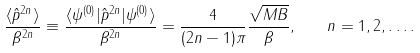<formula> <loc_0><loc_0><loc_500><loc_500>\frac { \langle \hat { p } ^ { 2 n } \rangle } { \beta ^ { 2 n } } \equiv \frac { \langle \psi ^ { ( 0 ) } | \hat { p } ^ { 2 n } | \psi ^ { ( 0 ) } \rangle } { \beta ^ { 2 n } } = \frac { 4 } { ( 2 n - 1 ) \pi } \frac { \sqrt { M B } } { \beta } , \quad n = 1 , 2 , \dots .</formula> 